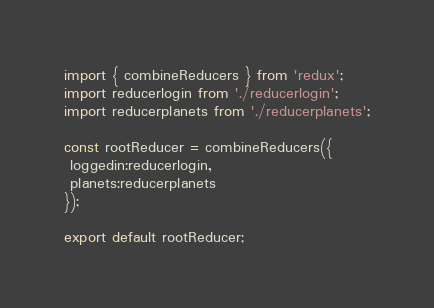Convert code to text. <code><loc_0><loc_0><loc_500><loc_500><_JavaScript_>import { combineReducers } from 'redux';
import reducerlogin from './reducerlogin';
import reducerplanets from './reducerplanets';

const rootReducer = combineReducers({
 loggedin:reducerlogin,
 planets:reducerplanets
});

export default rootReducer;
</code> 